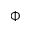Convert formula to latex. <formula><loc_0><loc_0><loc_500><loc_500>\Phi</formula> 